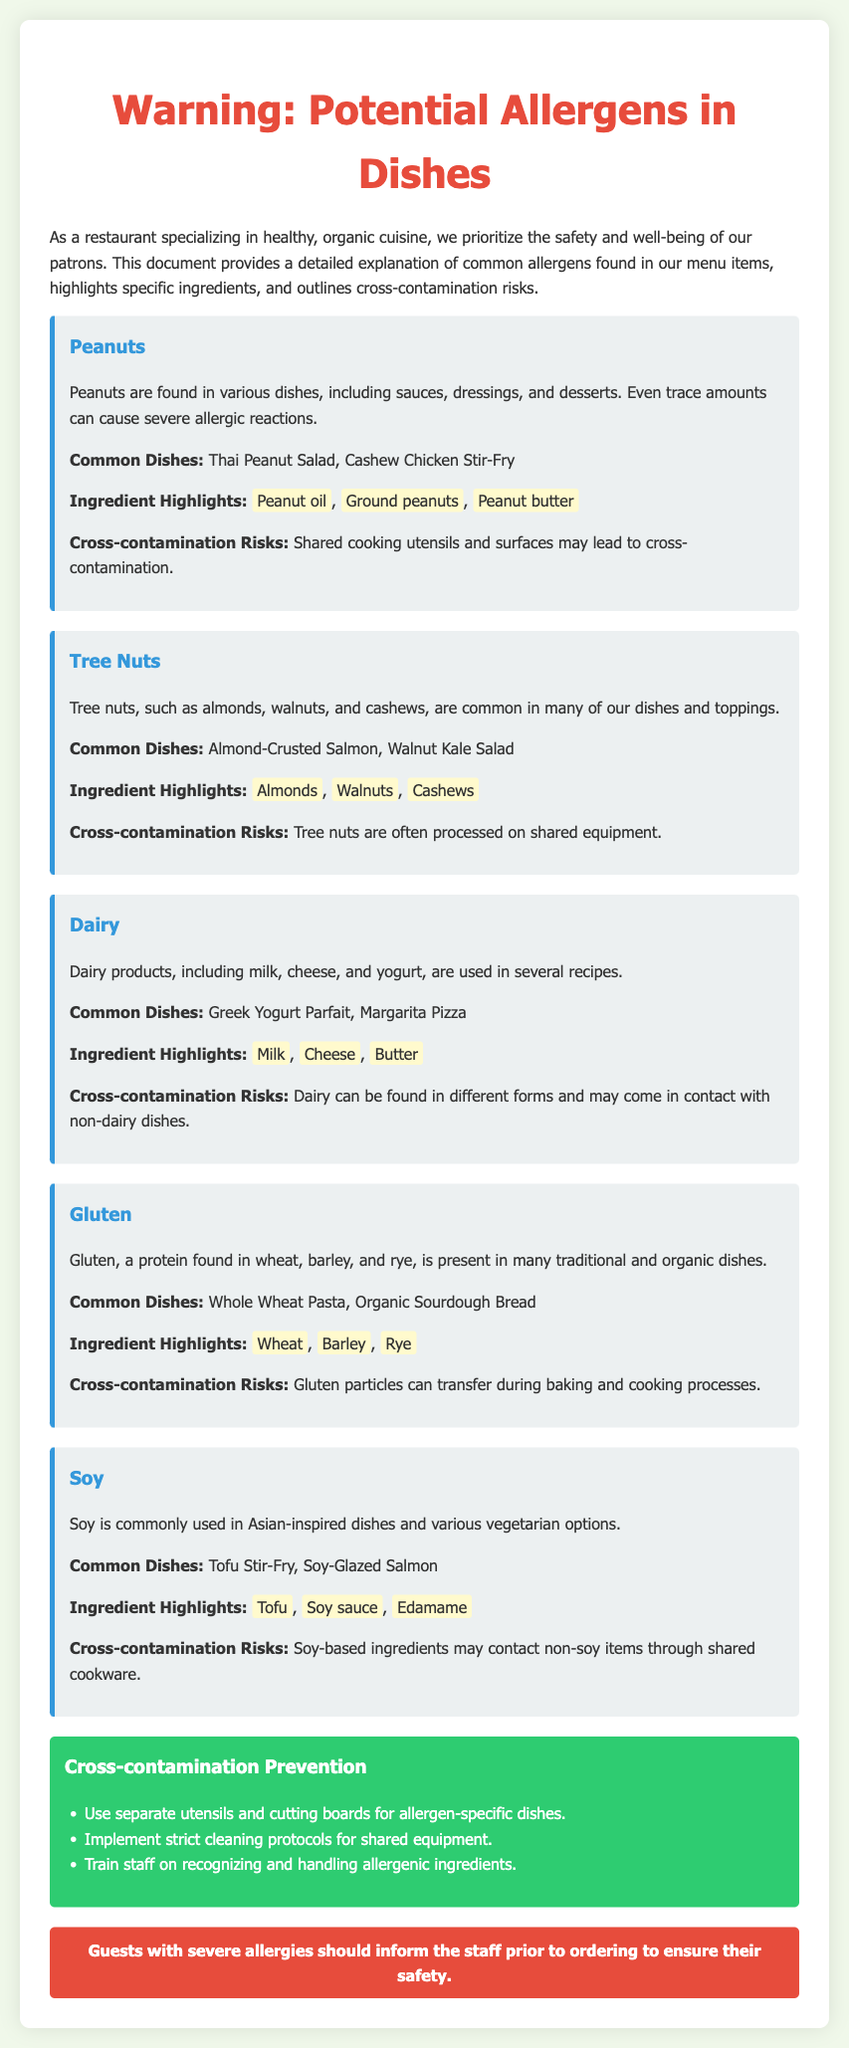What are common dishes that contain peanuts? The document lists specific dishes that include peanuts, such as Thai Peanut Salad and Cashew Chicken Stir-Fry.
Answer: Thai Peanut Salad, Cashew Chicken Stir-Fry What are common allergens mentioned in the document? The document highlights several allergens: Peanuts, Tree Nuts, Dairy, Gluten, and Soy.
Answer: Peanuts, Tree Nuts, Dairy, Gluten, Soy What is a highlighted ingredient in the tree nuts section? The document specifies highlighted ingredients associated with tree nuts, which include Almonds, Walnuts, and Cashews.
Answer: Almonds How can cross-contamination with gluten occur? The document explains that gluten particles can transfer during baking and cooking processes, leading to cross-contamination.
Answer: Baking and cooking processes What should guests with severe allergies do before ordering? The document advises guests with severe allergies to inform the staff prior to ordering to ensure their safety.
Answer: Inform the staff What is one of the prevention methods for cross-contamination? The document lists several prevention methods, including using separate utensils and cutting boards for allergen-specific dishes.
Answer: Separate utensils and cutting boards Which allergen is commonly found in Asian-inspired dishes? The document notes that soy is commonly used in Asian-inspired dishes and various vegetarian options.
Answer: Soy What are ingredient highlights in the dairy section? The document provides ingredient highlights for dairy, including Milk, Cheese, and Butter.
Answer: Milk, Cheese, Butter 